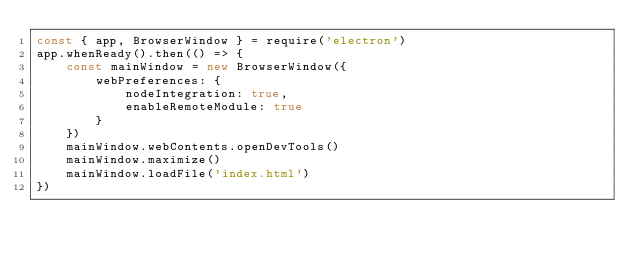Convert code to text. <code><loc_0><loc_0><loc_500><loc_500><_JavaScript_>const { app, BrowserWindow } = require('electron')
app.whenReady().then(() => {
    const mainWindow = new BrowserWindow({
        webPreferences: {
            nodeIntegration: true,
            enableRemoteModule: true
        }
    })
    mainWindow.webContents.openDevTools()
    mainWindow.maximize()
    mainWindow.loadFile('index.html')
})</code> 